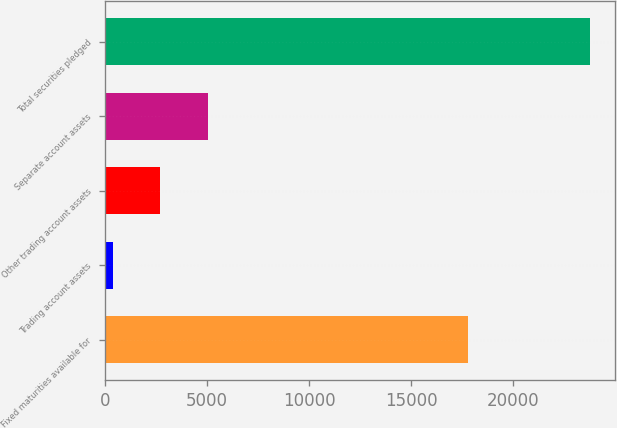Convert chart to OTSL. <chart><loc_0><loc_0><loc_500><loc_500><bar_chart><fcel>Fixed maturities available for<fcel>Trading account assets<fcel>Other trading account assets<fcel>Separate account assets<fcel>Total securities pledged<nl><fcel>17798<fcel>374<fcel>2715.9<fcel>5057.8<fcel>23793<nl></chart> 